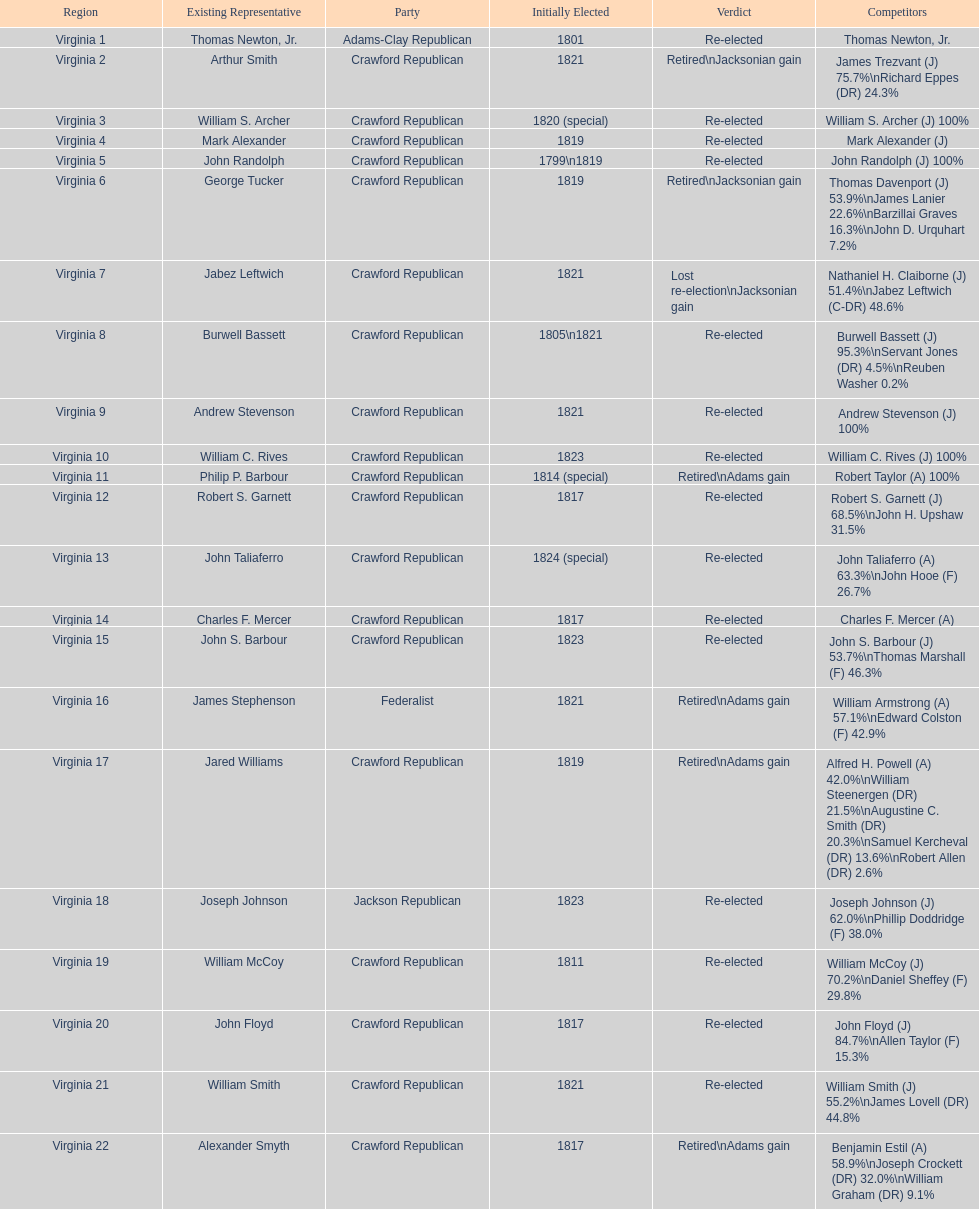Which jacksonian candidates got at least 76% of the vote in their races? Arthur Smith. 